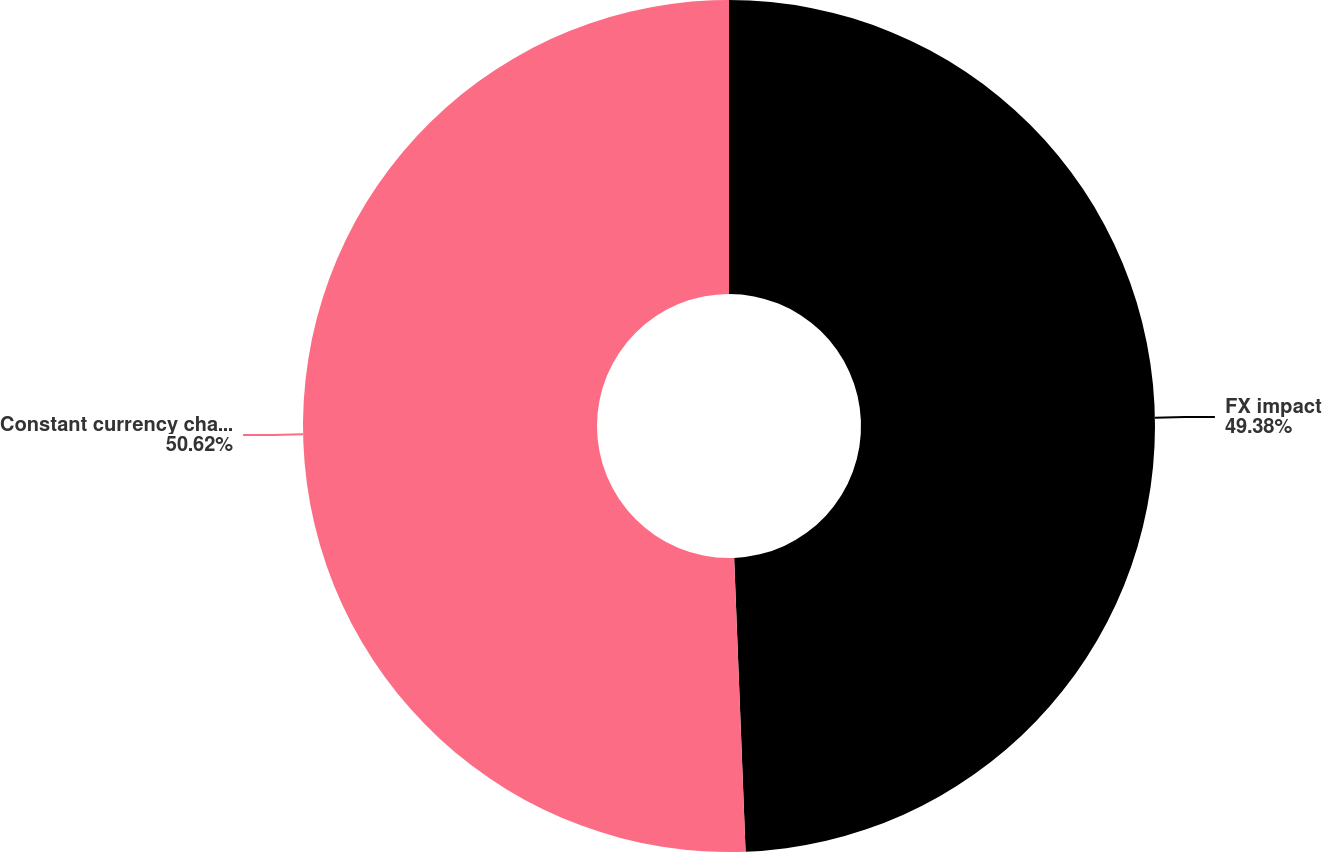Convert chart to OTSL. <chart><loc_0><loc_0><loc_500><loc_500><pie_chart><fcel>FX impact<fcel>Constant currency change<nl><fcel>49.38%<fcel>50.62%<nl></chart> 